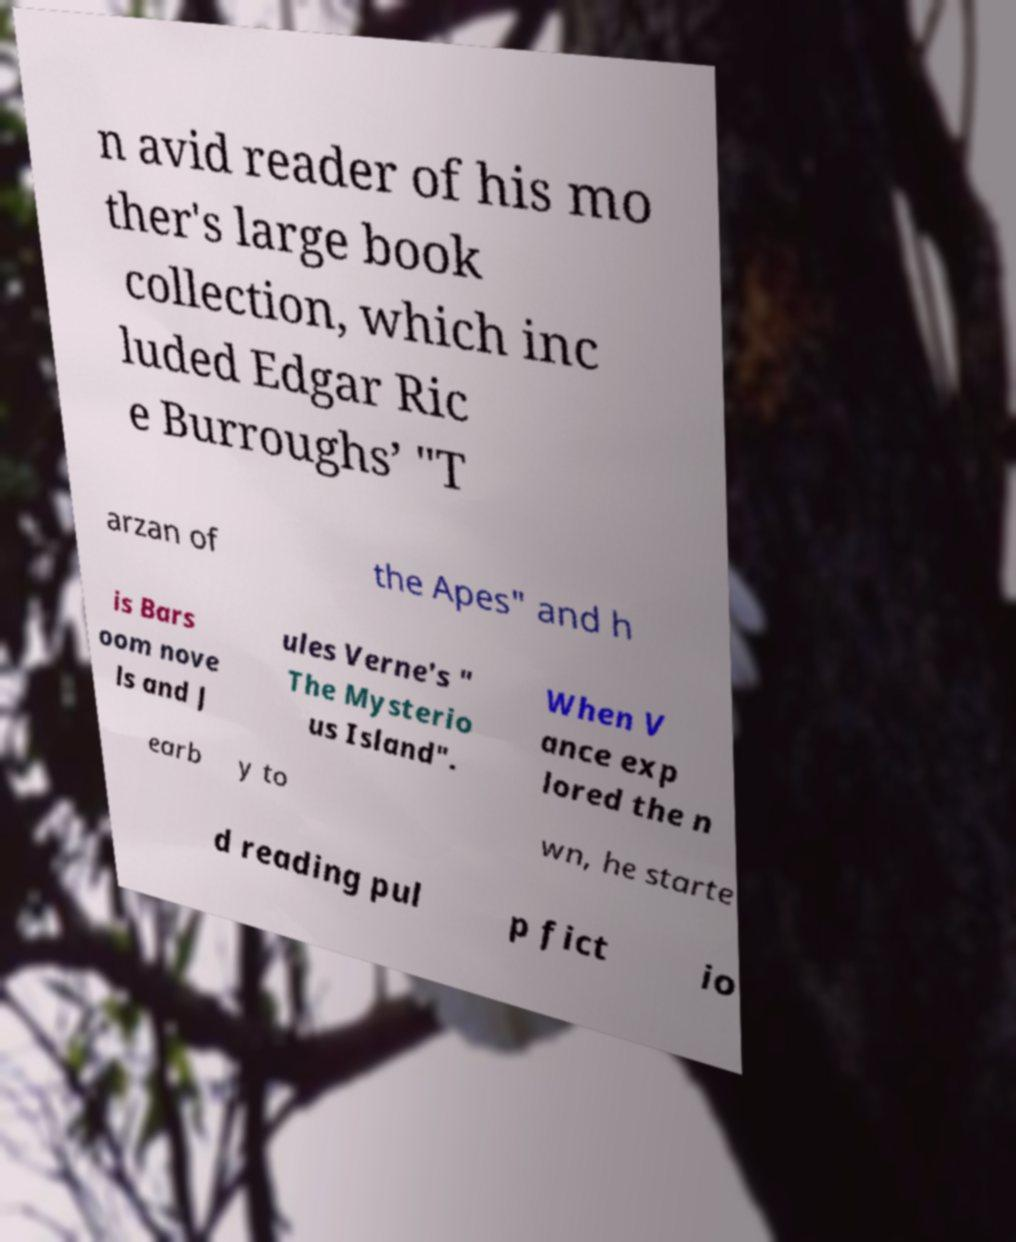There's text embedded in this image that I need extracted. Can you transcribe it verbatim? n avid reader of his mo ther's large book collection, which inc luded Edgar Ric e Burroughs’ "T arzan of the Apes" and h is Bars oom nove ls and J ules Verne's " The Mysterio us Island". When V ance exp lored the n earb y to wn, he starte d reading pul p fict io 